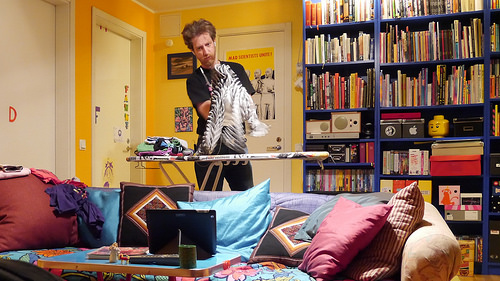<image>
Can you confirm if the book is on the shelf? Yes. Looking at the image, I can see the book is positioned on top of the shelf, with the shelf providing support. Is there a sofa under the pillow? Yes. The sofa is positioned underneath the pillow, with the pillow above it in the vertical space. 